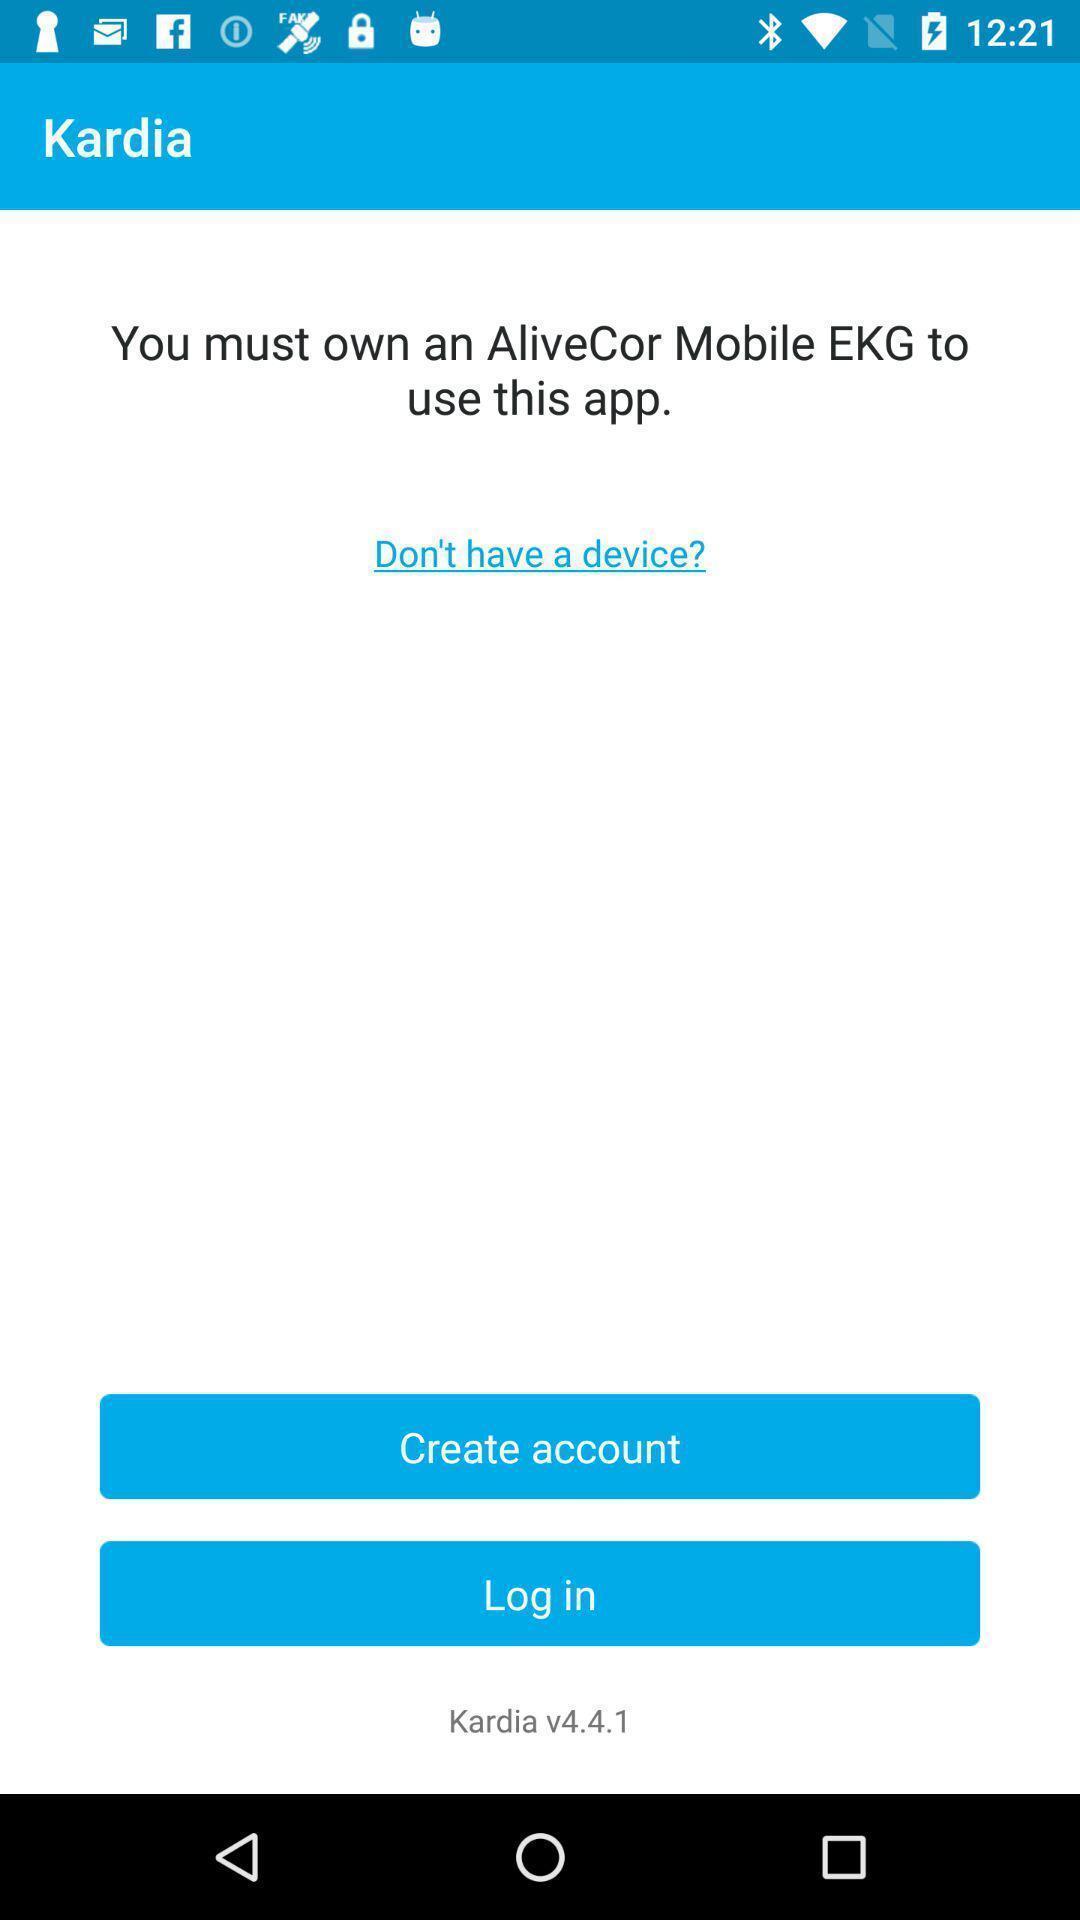Summarize the information in this screenshot. Welcome page. 